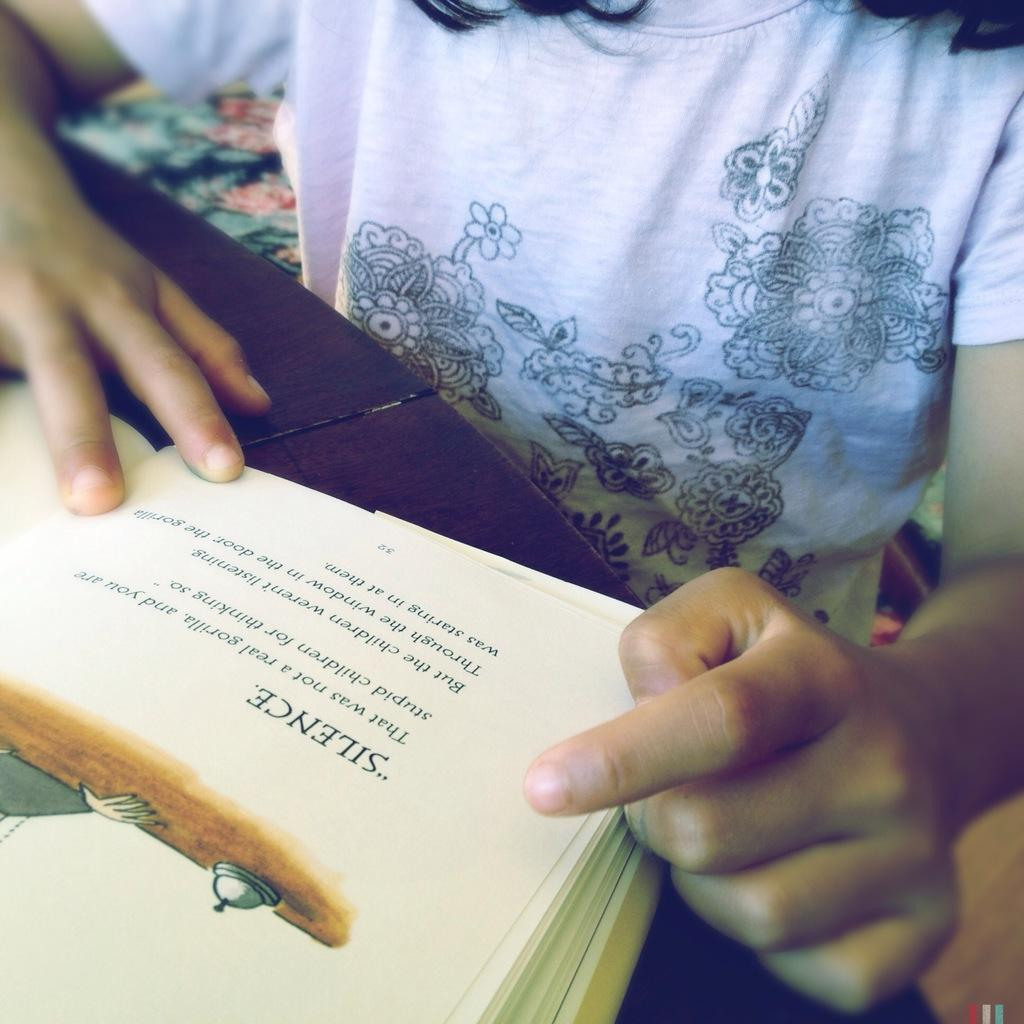<image>
Present a compact description of the photo's key features. A young person reading a book with the word Silence at the top. 